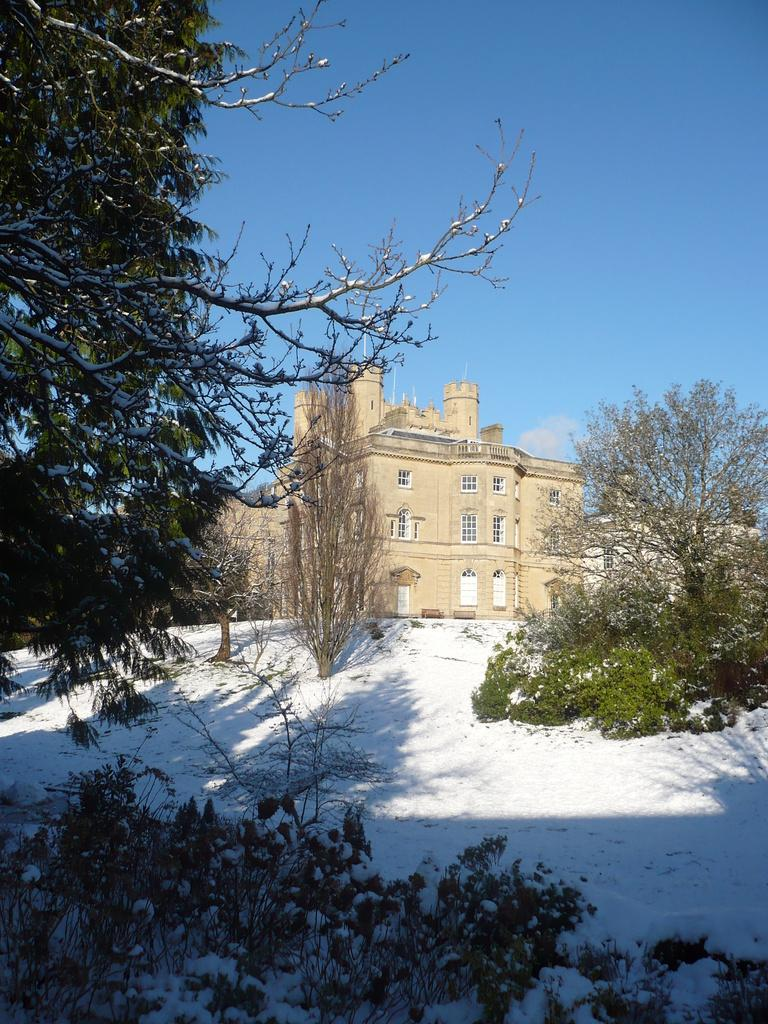What type of structures can be seen in the image? There are buildings in the image. What other natural elements are present in the image? There are plants and trees in the image. What is the weather like in the image? There is snow in the image, indicating a cold or wintery environment. What can be seen in the background of the image? The sky is visible in the background of the image. Where is the donkey's nest located in the image? There is no donkey or nest present in the image. How many cents can be seen on the ground in the image? There are no cents visible in the image. 